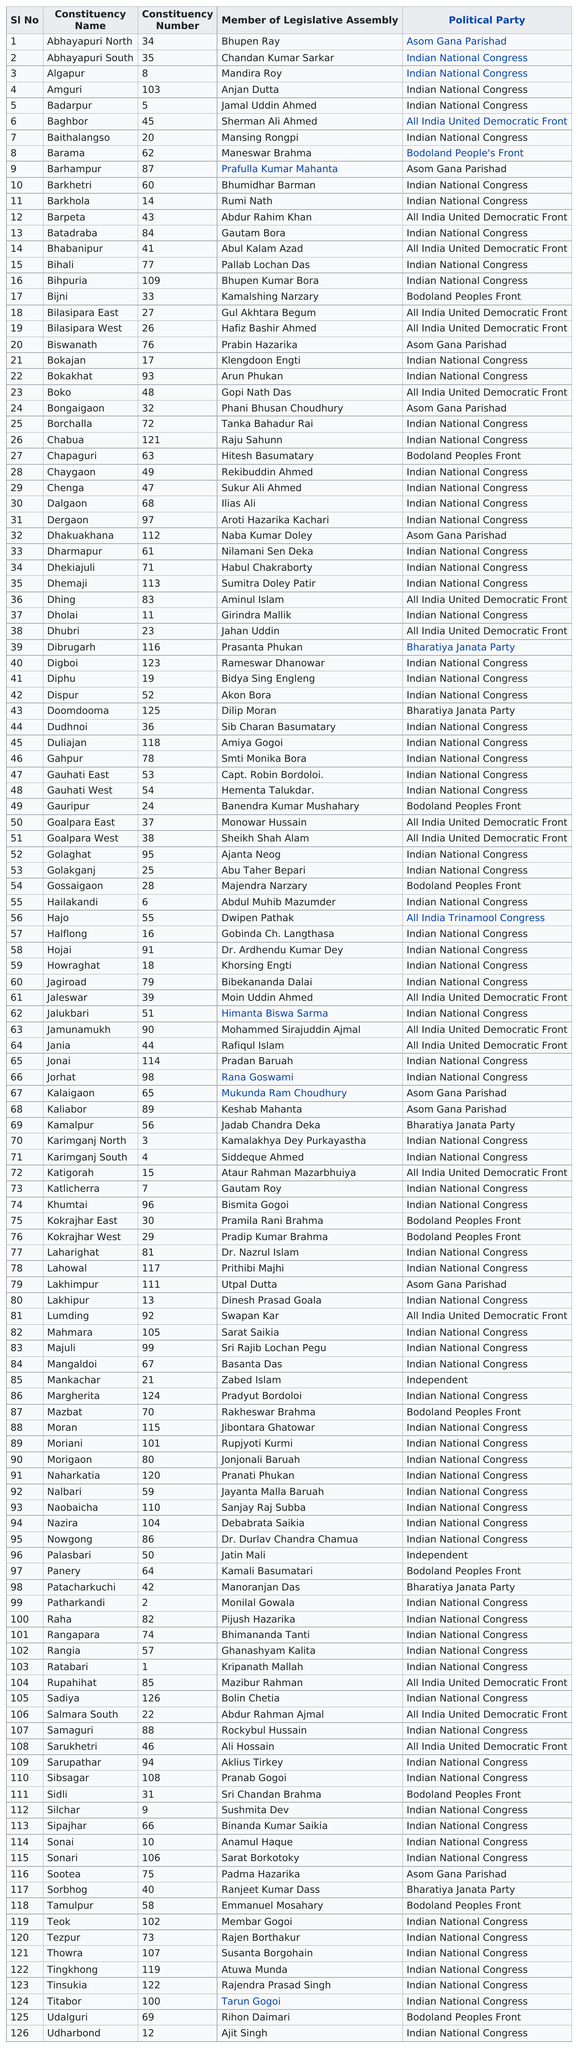Draw attention to some important aspects in this diagram. Rumi Nath is the only person with the number 14. Mandira Roy is predominantly prior to Anjan Dutta, who is prior to the person known as 'whoj'. The Indian National Congress has the most members representing it. Ratabari constituencies are those that have only one representative. Previously, the constituency associated with the Asom Gana Parishad was Abhayapuri North. 